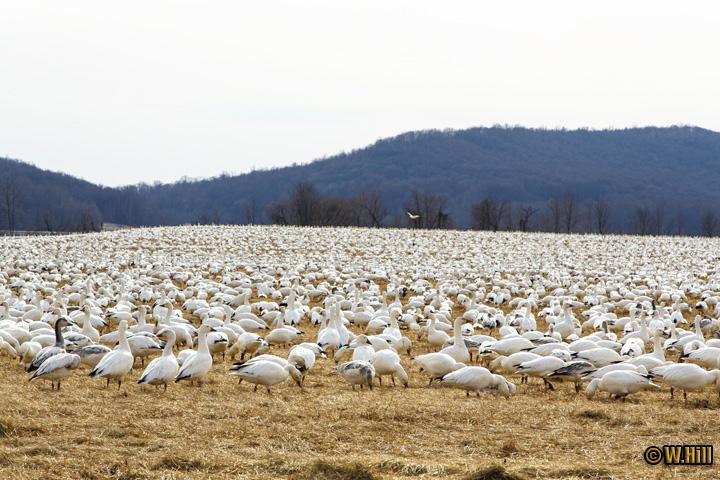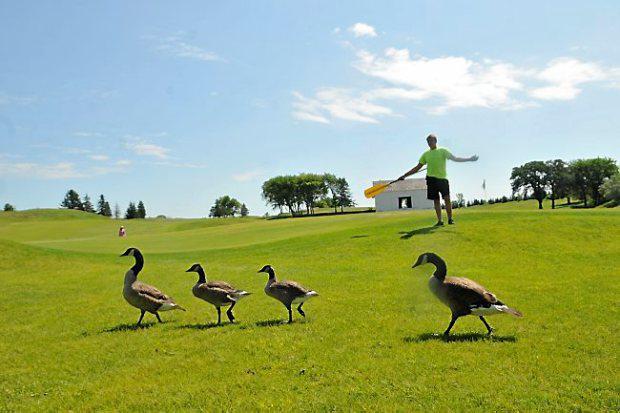The first image is the image on the left, the second image is the image on the right. Assess this claim about the two images: "An image shows a man holding out some type of stick while standing on a green field behind ducks.". Correct or not? Answer yes or no. Yes. The first image is the image on the left, the second image is the image on the right. Given the left and right images, does the statement "One of the images shows a person holding a stick." hold true? Answer yes or no. Yes. 